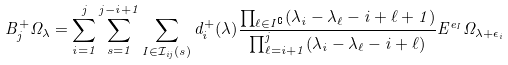Convert formula to latex. <formula><loc_0><loc_0><loc_500><loc_500>B _ { j } ^ { + } \Omega _ { \lambda } = \sum _ { i = 1 } ^ { j } \sum _ { s = 1 } ^ { j - i + 1 } \sum _ { I \in \mathcal { I } _ { i j } ( s ) } d _ { i } ^ { + } ( \lambda ) \frac { \prod _ { \ell \in I ^ { \complement } } ( \lambda _ { i } - \lambda _ { \ell } - i + \ell + 1 ) } { \prod _ { \ell = i + 1 } ^ { j } ( \lambda _ { i } - \lambda _ { \ell } - i + \ell ) } E ^ { e _ { I } } \Omega _ { \lambda + \epsilon _ { i } }</formula> 